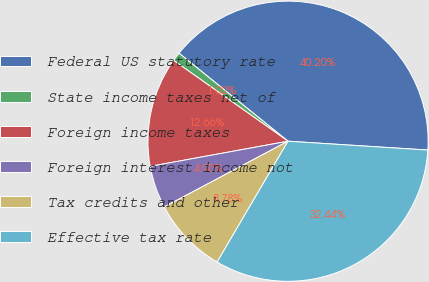Convert chart to OTSL. <chart><loc_0><loc_0><loc_500><loc_500><pie_chart><fcel>Federal US statutory rate<fcel>State income taxes net of<fcel>Foreign income taxes<fcel>Foreign interest income not<fcel>Tax credits and other<fcel>Effective tax rate<nl><fcel>40.19%<fcel>1.02%<fcel>12.66%<fcel>4.9%<fcel>8.78%<fcel>32.43%<nl></chart> 